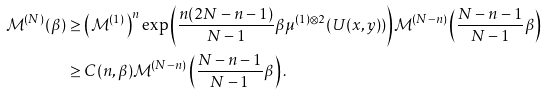Convert formula to latex. <formula><loc_0><loc_0><loc_500><loc_500>\mathcal { M } ^ { ( N ) } ( \beta ) & \geq \left ( \mathcal { M } ^ { ( 1 ) } \right ) ^ { n } \exp { \left ( \frac { n ( 2 N - n - 1 ) } { N - 1 } \beta \mu ^ { ( 1 ) \otimes 2 } ( U ( x , y ) ) \right ) } \mathcal { M } ^ { ( N - n ) } \left ( \frac { N - n - 1 } { N - 1 } \beta \right ) \\ & \geq C ( n , \beta ) \mathcal { M } ^ { ( N - n ) } \left ( \frac { N - n - 1 } { N - 1 } \beta \right ) .</formula> 